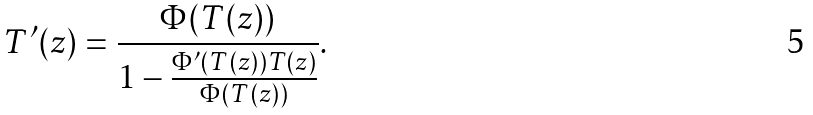<formula> <loc_0><loc_0><loc_500><loc_500>T ^ { \prime } ( z ) = \frac { \Phi ( T ( z ) ) } { 1 - \frac { \Phi ^ { \prime } ( T ( z ) ) T ( z ) } { \Phi ( T ( z ) ) } } .</formula> 